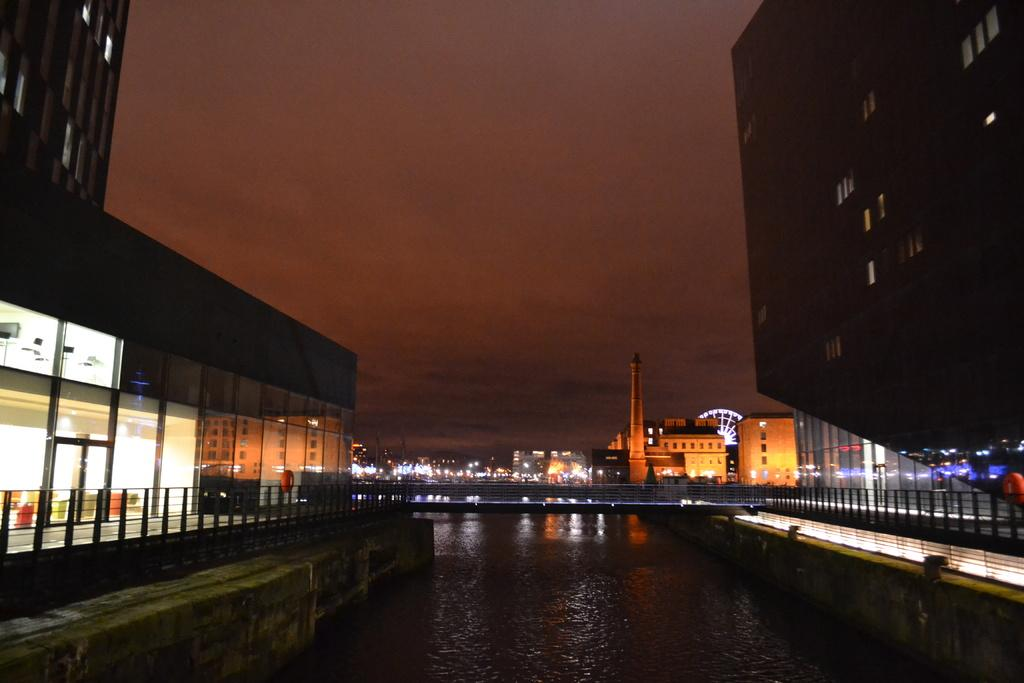What type of structures can be seen in the image? There are buildings in the image. What material is used for some of the structures in the image? Metal rods are present in the image. What can be seen illuminating the scene in the image? Lights are visible in the image. What natural element is present in the image? There is water in the image. What attractions can be seen in the background of the image? In the background, there is a giant wheel and a tower. What type of knee injury can be seen in the image? There is no knee injury present in the image. What ideas are being discussed by the people in the image? There are no people present in the image, so it is impossible to determine what ideas might be discussed. 